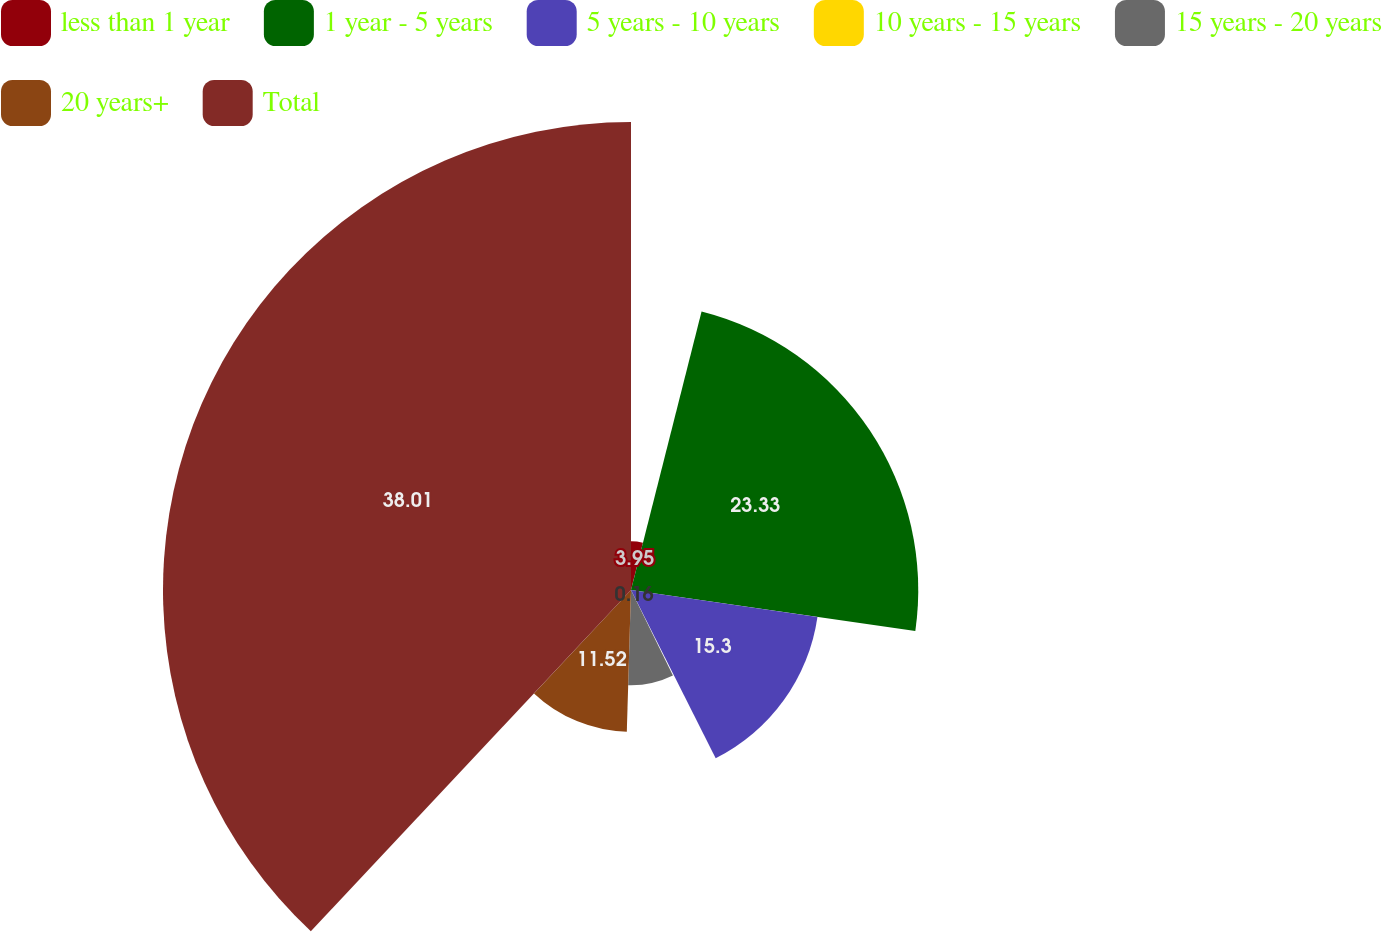Convert chart to OTSL. <chart><loc_0><loc_0><loc_500><loc_500><pie_chart><fcel>less than 1 year<fcel>1 year - 5 years<fcel>5 years - 10 years<fcel>10 years - 15 years<fcel>15 years - 20 years<fcel>20 years+<fcel>Total<nl><fcel>3.95%<fcel>23.33%<fcel>15.3%<fcel>0.16%<fcel>7.73%<fcel>11.52%<fcel>38.01%<nl></chart> 